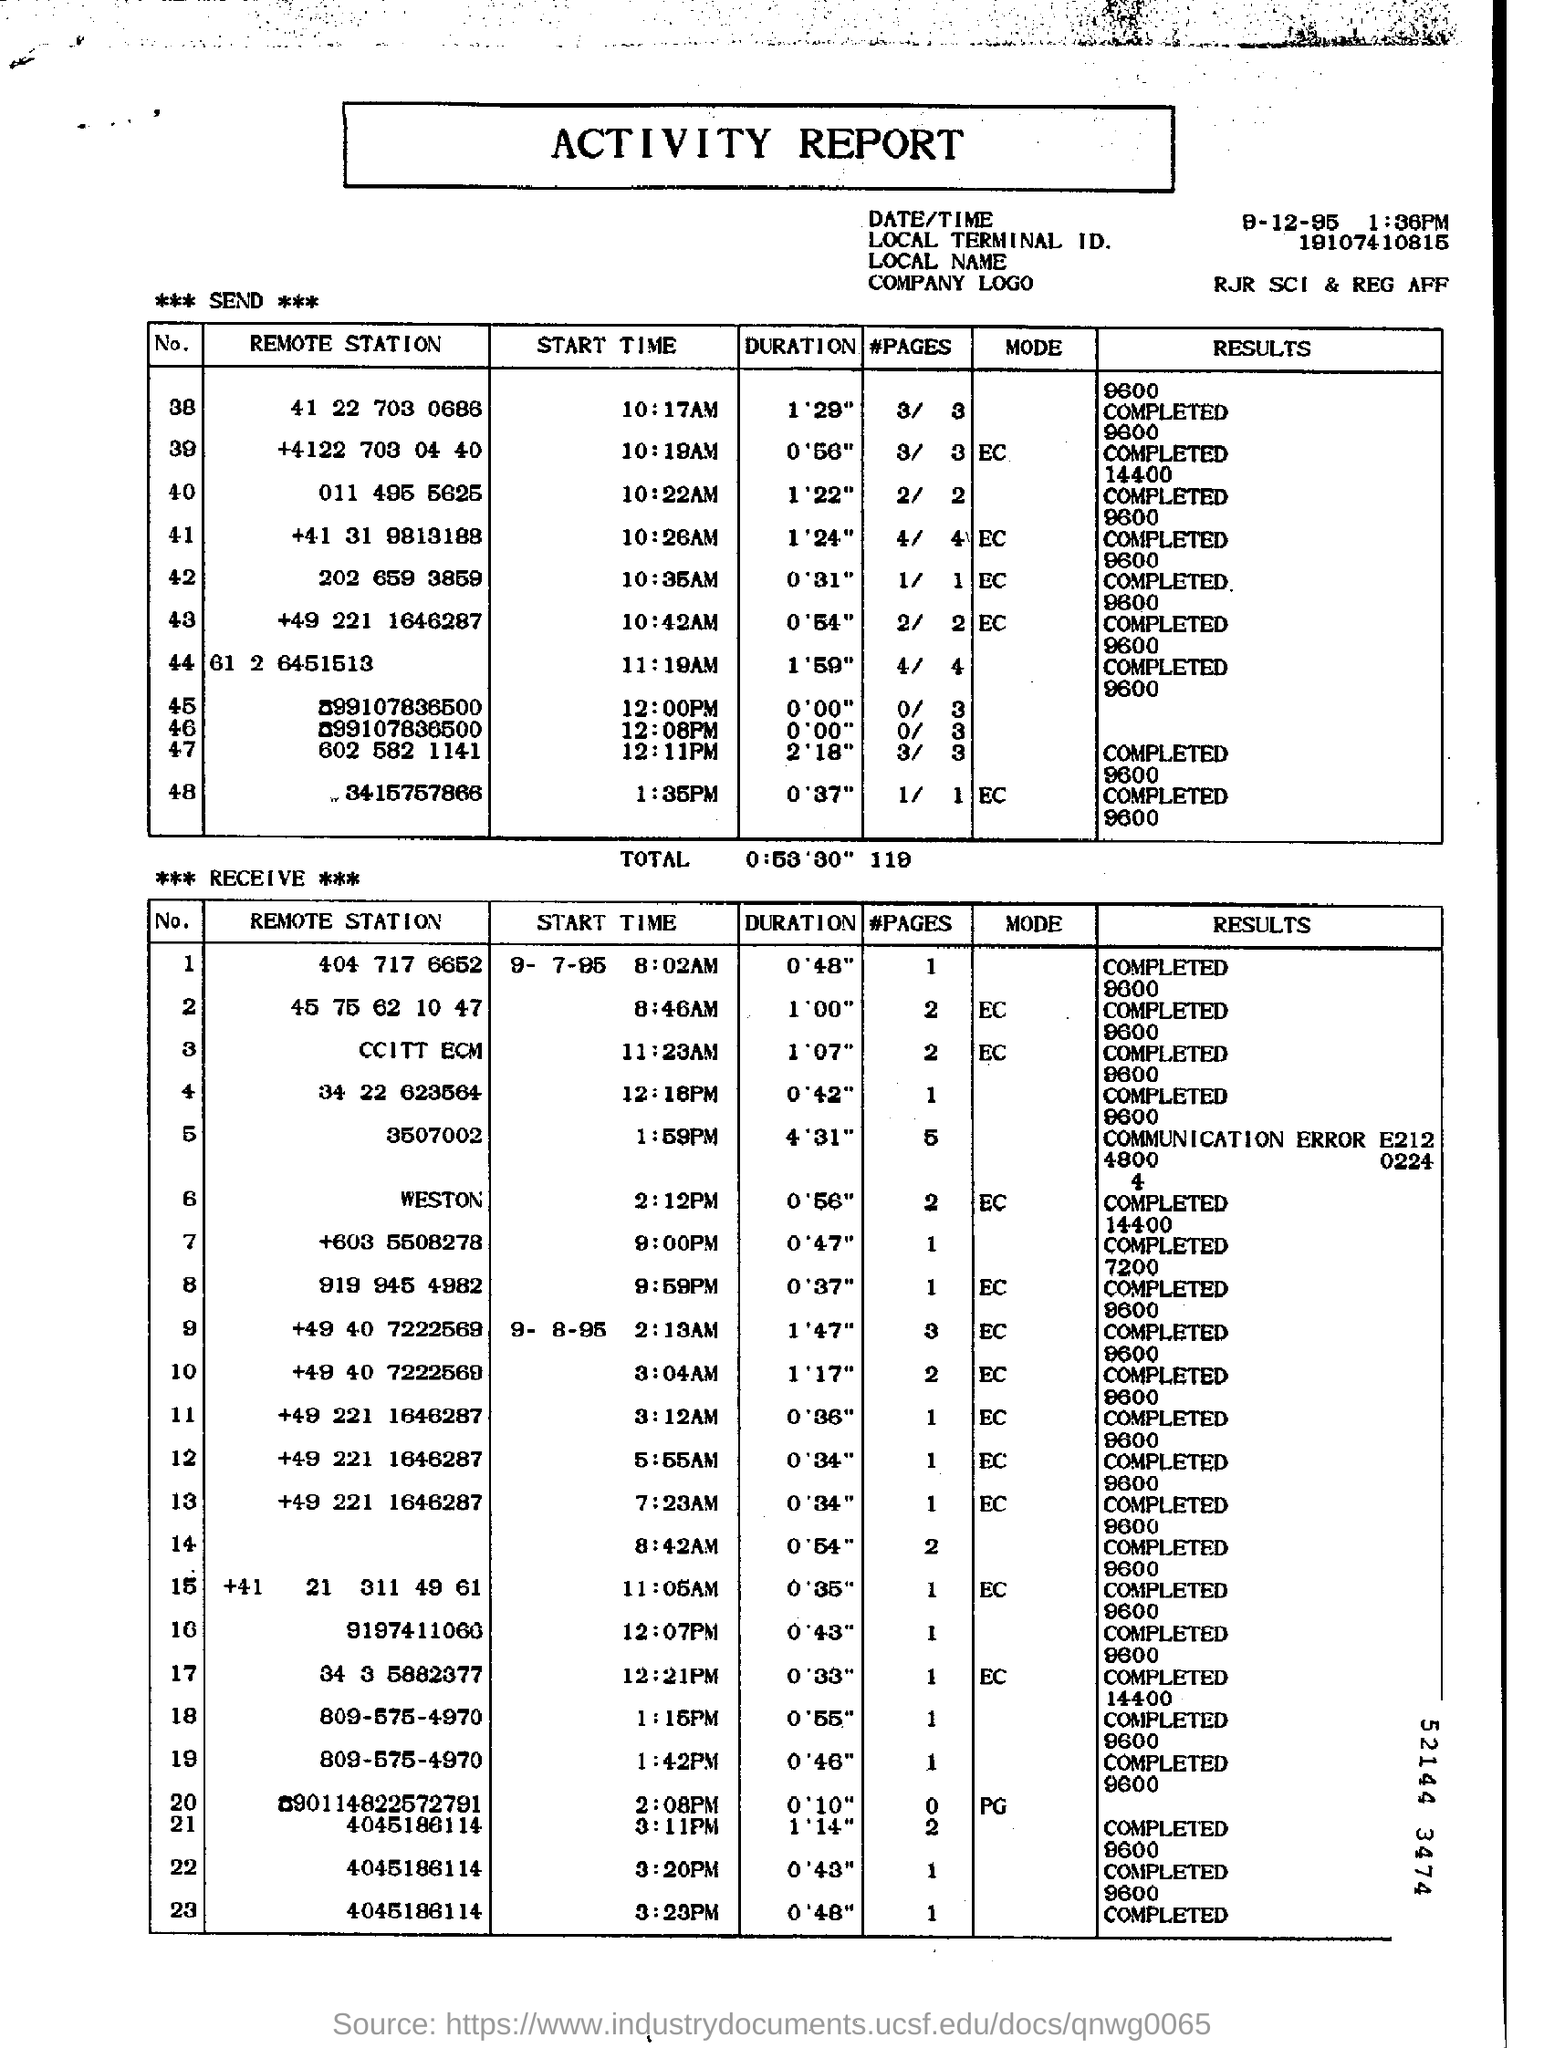Highlight a few significant elements in this photo. The duration for the remote station number 603 5508278 is 0 minutes and 47 seconds. The message states that the "START TIME" for the "Remote Station" with the identifier "011 4955625" is 10:22 a.m. The start time for the remote station with the phone number +603 5508278 is 9:00 PM. The duration for the remote station number "202 659 3859" is 0 minutes and 31 seconds. The result for the remote station with the number "011 4955625" is 14400, which has been completed. 